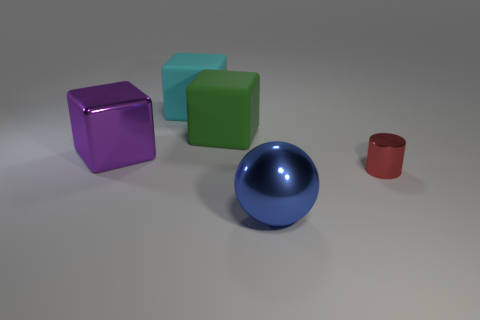There is another big rubber object that is the same shape as the large green object; what color is it?
Make the answer very short. Cyan. Is the material of the sphere that is in front of the large cyan cube the same as the purple cube?
Give a very brief answer. Yes. How many tiny things are either green rubber blocks or cyan cylinders?
Give a very brief answer. 0. How big is the cylinder?
Your response must be concise. Small. There is a red thing; does it have the same size as the thing that is in front of the cylinder?
Offer a very short reply. No. What number of brown objects are either large rubber objects or cubes?
Give a very brief answer. 0. What number of small metal things are there?
Provide a short and direct response. 1. How big is the metal object that is left of the big blue ball?
Your response must be concise. Large. Do the ball and the purple cube have the same size?
Give a very brief answer. Yes. How many things are shiny cylinders or big cubes that are on the right side of the big metal cube?
Your answer should be compact. 3. 